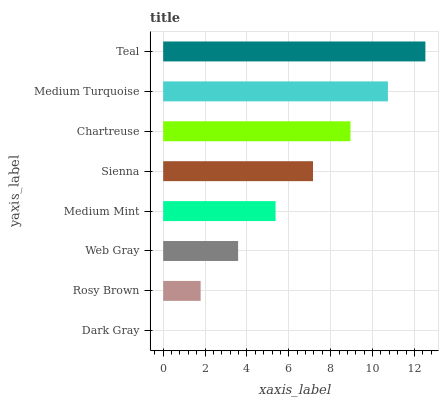Is Dark Gray the minimum?
Answer yes or no. Yes. Is Teal the maximum?
Answer yes or no. Yes. Is Rosy Brown the minimum?
Answer yes or no. No. Is Rosy Brown the maximum?
Answer yes or no. No. Is Rosy Brown greater than Dark Gray?
Answer yes or no. Yes. Is Dark Gray less than Rosy Brown?
Answer yes or no. Yes. Is Dark Gray greater than Rosy Brown?
Answer yes or no. No. Is Rosy Brown less than Dark Gray?
Answer yes or no. No. Is Sienna the high median?
Answer yes or no. Yes. Is Medium Mint the low median?
Answer yes or no. Yes. Is Medium Turquoise the high median?
Answer yes or no. No. Is Dark Gray the low median?
Answer yes or no. No. 